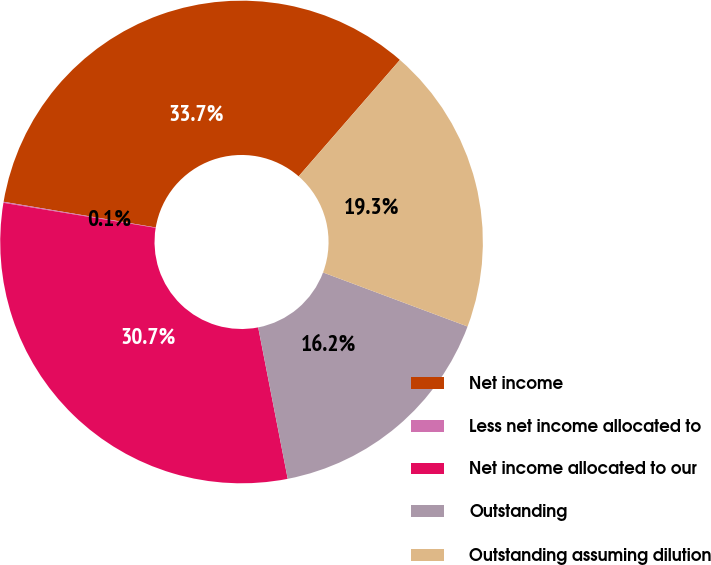Convert chart to OTSL. <chart><loc_0><loc_0><loc_500><loc_500><pie_chart><fcel>Net income<fcel>Less net income allocated to<fcel>Net income allocated to our<fcel>Outstanding<fcel>Outstanding assuming dilution<nl><fcel>33.73%<fcel>0.07%<fcel>30.66%<fcel>16.24%<fcel>19.3%<nl></chart> 